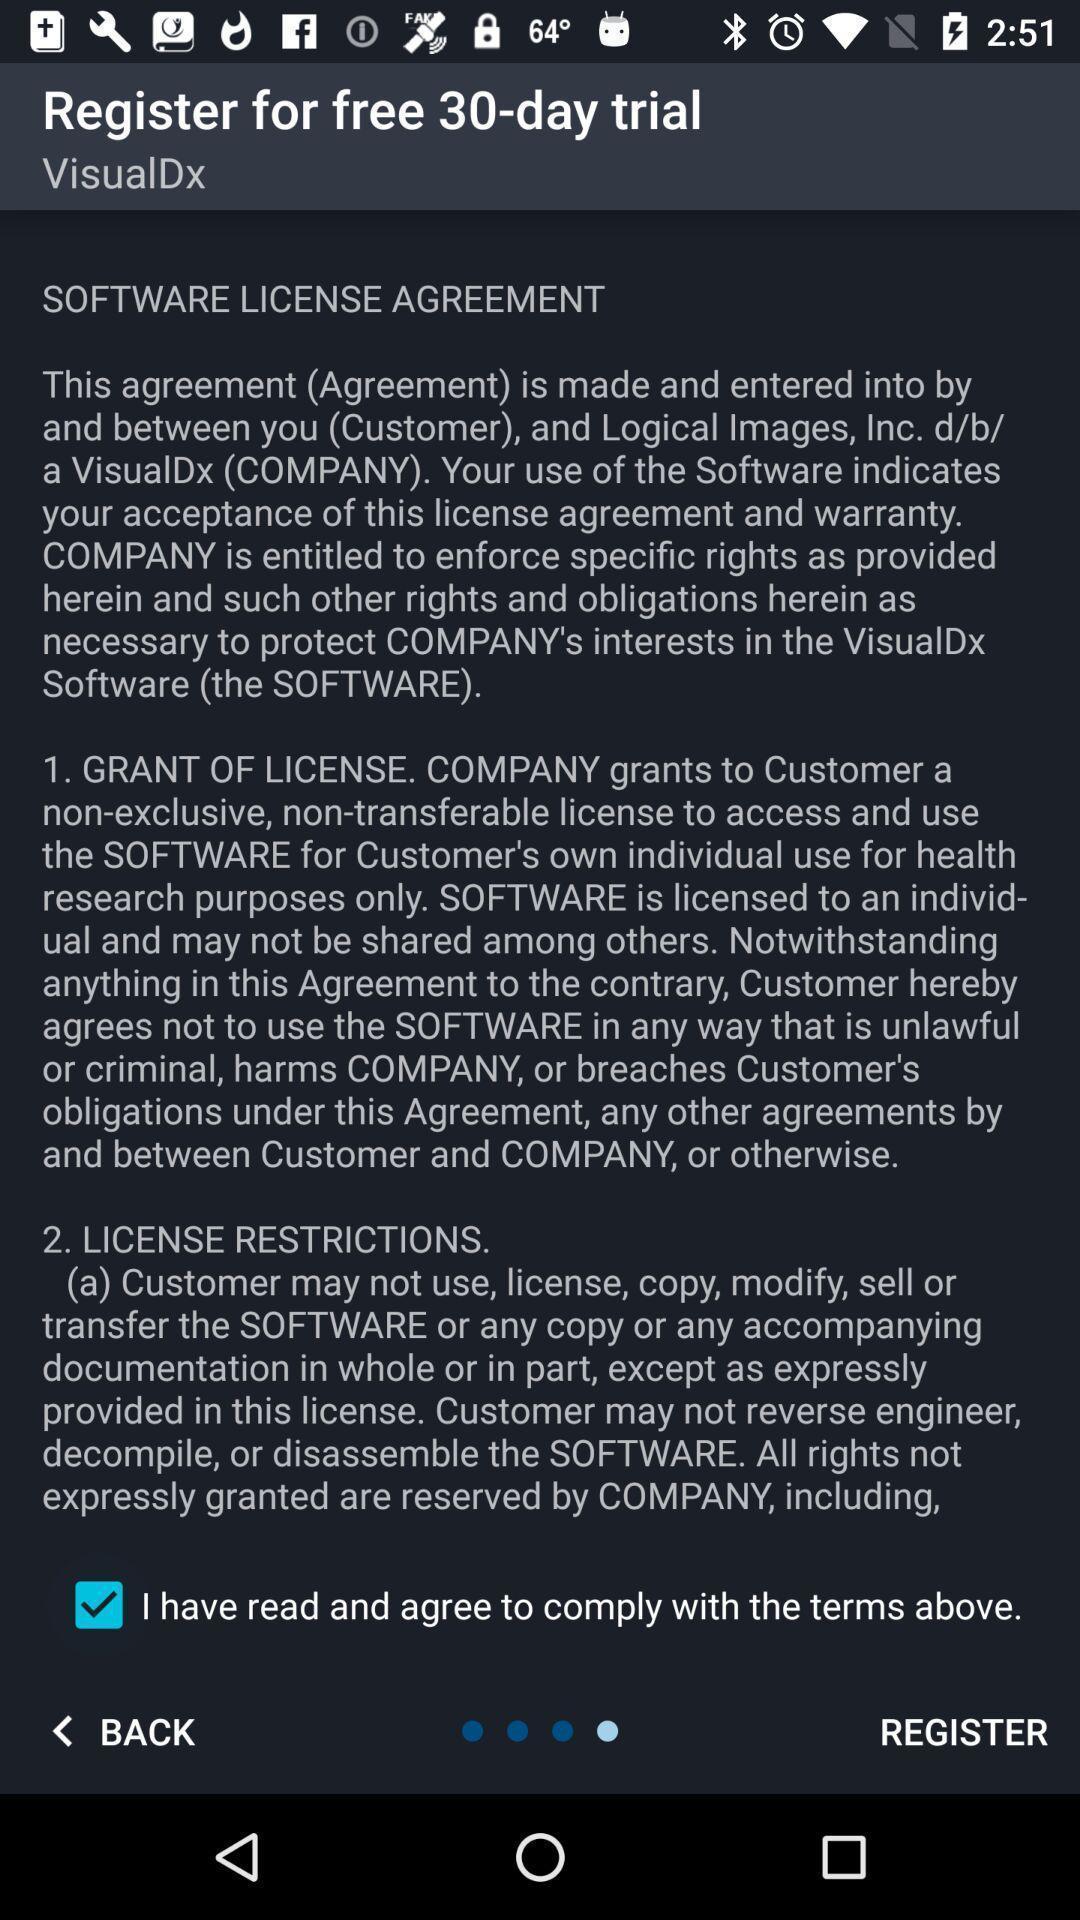Summarize the main components in this picture. Page showing details about software license agreement. 